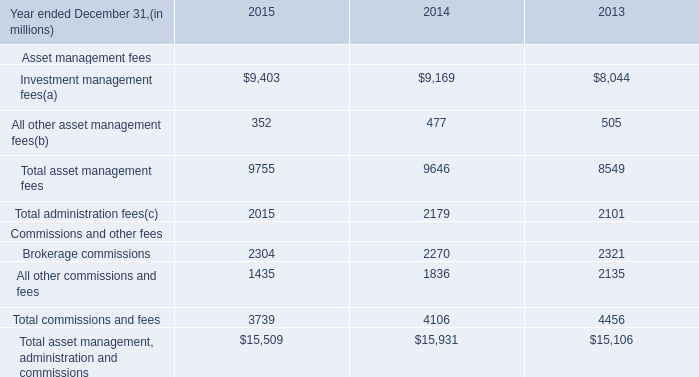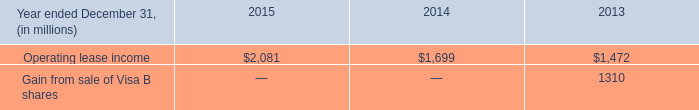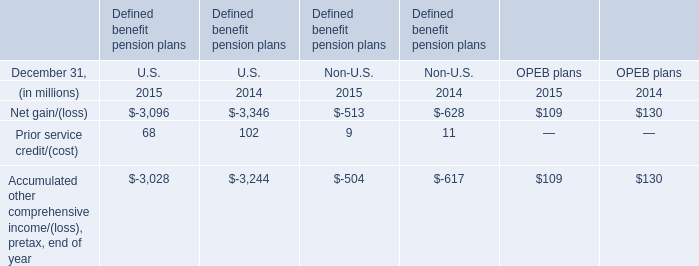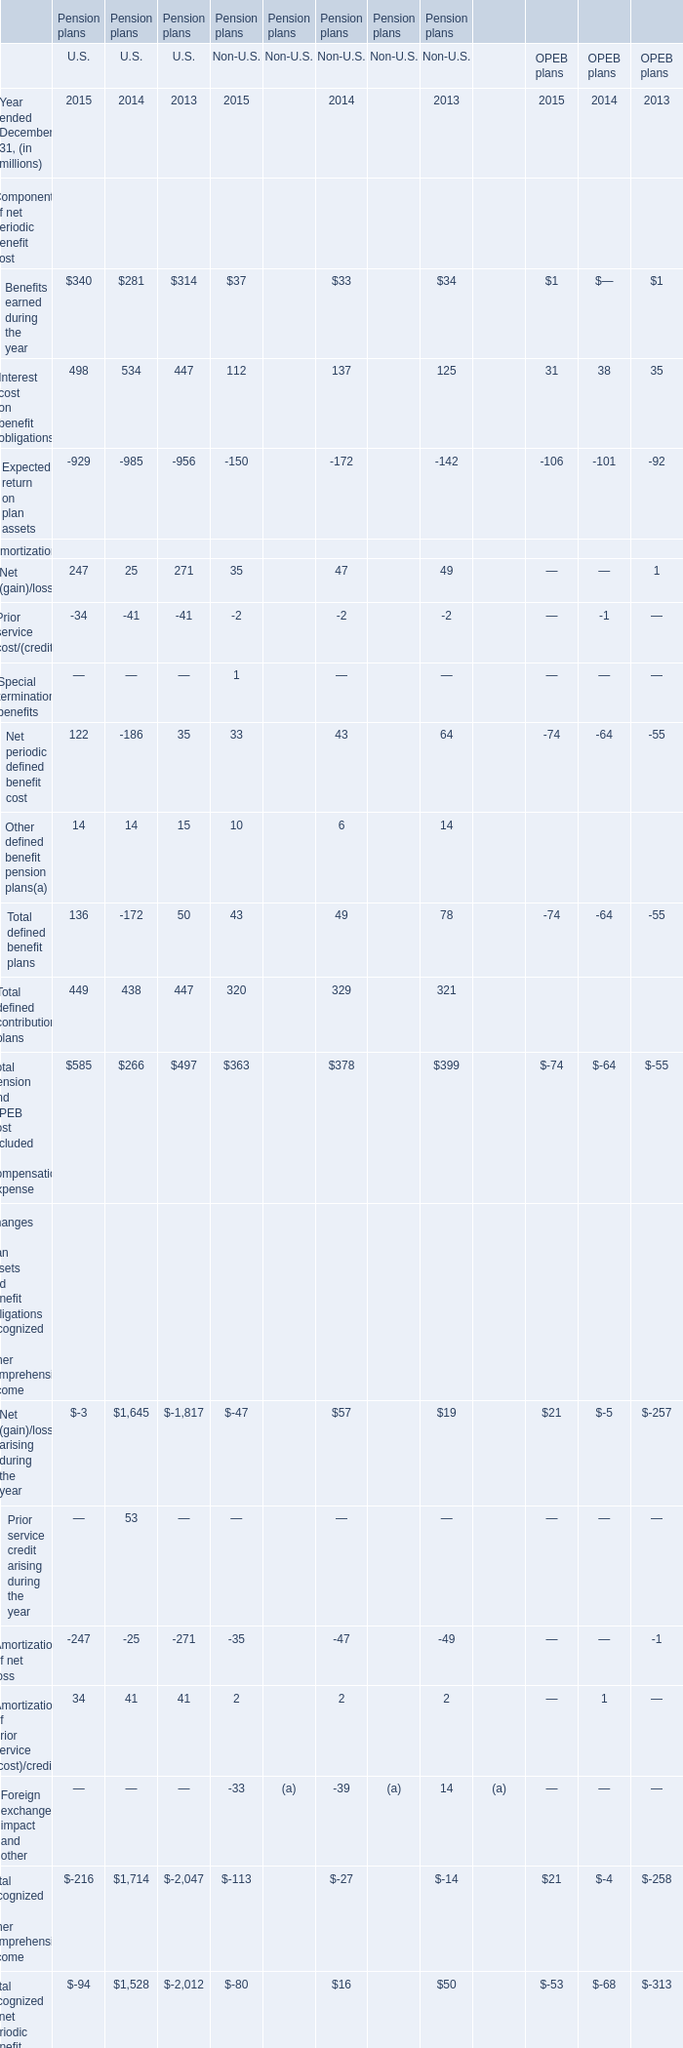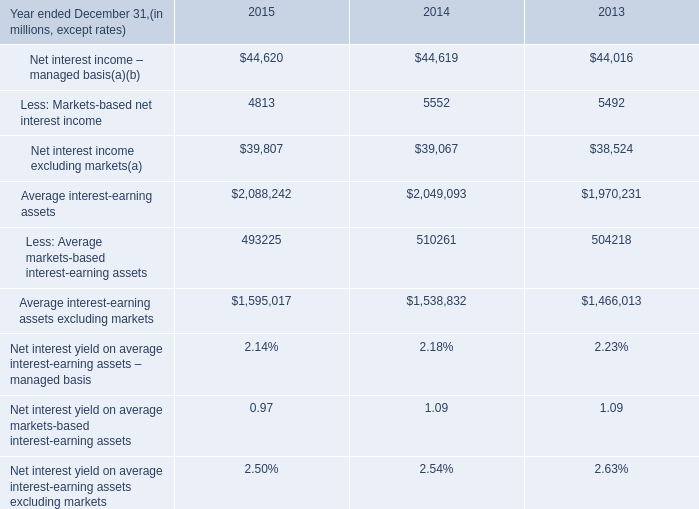What is the total amount of Operating lease income of 2013, and Net interest income – managed basis of 2014 ? 
Computations: (1472.0 + 44619.0)
Answer: 46091.0. 